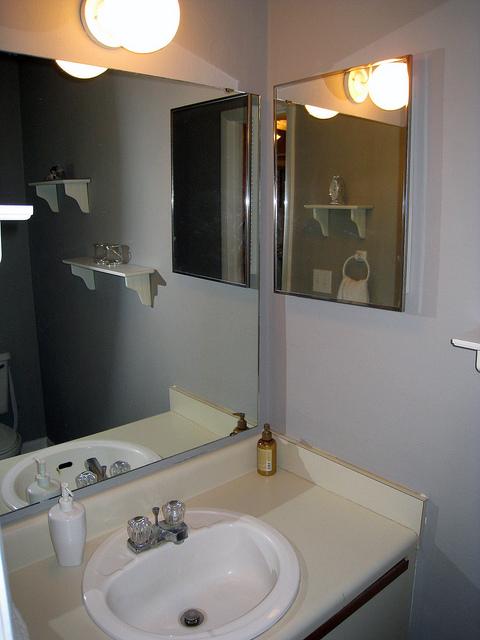How many mirrors are in the room?
Give a very brief answer. 2. Is the sink round?
Write a very short answer. Yes. What room is this?
Give a very brief answer. Bathroom. 